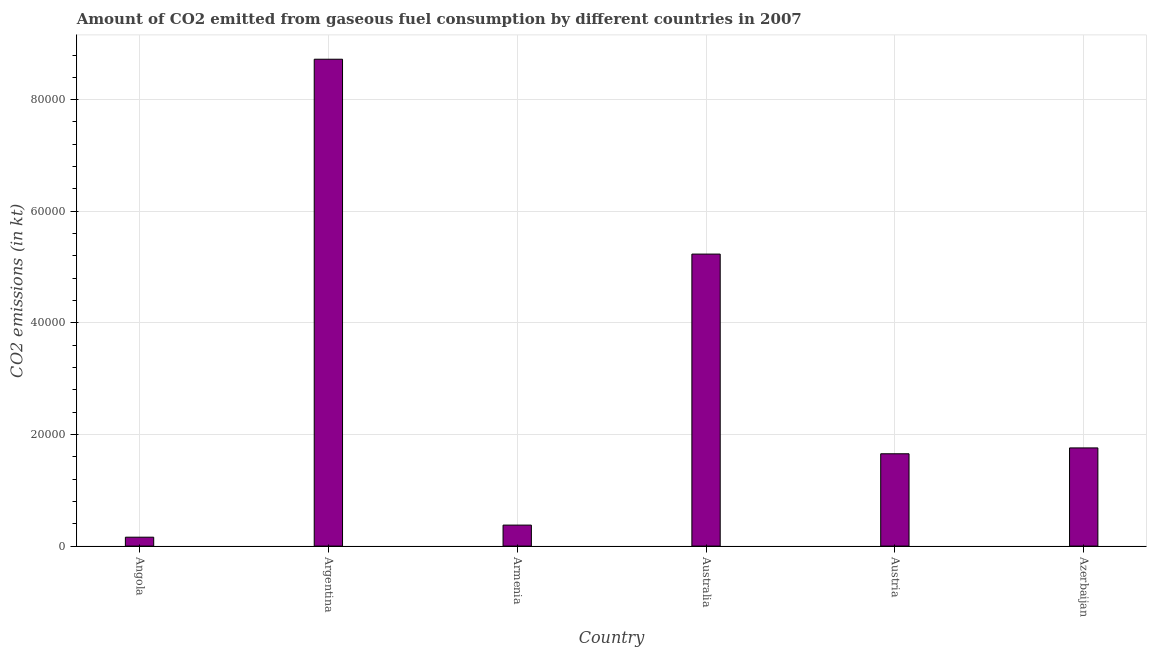Does the graph contain grids?
Offer a very short reply. Yes. What is the title of the graph?
Keep it short and to the point. Amount of CO2 emitted from gaseous fuel consumption by different countries in 2007. What is the label or title of the X-axis?
Offer a terse response. Country. What is the label or title of the Y-axis?
Give a very brief answer. CO2 emissions (in kt). What is the co2 emissions from gaseous fuel consumption in Armenia?
Offer a very short reply. 3762.34. Across all countries, what is the maximum co2 emissions from gaseous fuel consumption?
Ensure brevity in your answer.  8.72e+04. Across all countries, what is the minimum co2 emissions from gaseous fuel consumption?
Offer a terse response. 1595.14. In which country was the co2 emissions from gaseous fuel consumption maximum?
Your answer should be very brief. Argentina. In which country was the co2 emissions from gaseous fuel consumption minimum?
Offer a terse response. Angola. What is the sum of the co2 emissions from gaseous fuel consumption?
Ensure brevity in your answer.  1.79e+05. What is the difference between the co2 emissions from gaseous fuel consumption in Armenia and Australia?
Ensure brevity in your answer.  -4.86e+04. What is the average co2 emissions from gaseous fuel consumption per country?
Make the answer very short. 2.98e+04. What is the median co2 emissions from gaseous fuel consumption?
Give a very brief answer. 1.71e+04. What is the ratio of the co2 emissions from gaseous fuel consumption in Armenia to that in Australia?
Your answer should be very brief. 0.07. What is the difference between the highest and the second highest co2 emissions from gaseous fuel consumption?
Keep it short and to the point. 3.49e+04. Is the sum of the co2 emissions from gaseous fuel consumption in Argentina and Azerbaijan greater than the maximum co2 emissions from gaseous fuel consumption across all countries?
Offer a very short reply. Yes. What is the difference between the highest and the lowest co2 emissions from gaseous fuel consumption?
Your response must be concise. 8.57e+04. How many bars are there?
Make the answer very short. 6. Are all the bars in the graph horizontal?
Offer a very short reply. No. How many countries are there in the graph?
Offer a very short reply. 6. What is the difference between two consecutive major ticks on the Y-axis?
Offer a terse response. 2.00e+04. What is the CO2 emissions (in kt) of Angola?
Offer a very short reply. 1595.14. What is the CO2 emissions (in kt) in Argentina?
Your answer should be very brief. 8.72e+04. What is the CO2 emissions (in kt) in Armenia?
Your answer should be very brief. 3762.34. What is the CO2 emissions (in kt) in Australia?
Give a very brief answer. 5.23e+04. What is the CO2 emissions (in kt) of Austria?
Provide a succinct answer. 1.65e+04. What is the CO2 emissions (in kt) of Azerbaijan?
Offer a terse response. 1.76e+04. What is the difference between the CO2 emissions (in kt) in Angola and Argentina?
Provide a succinct answer. -8.57e+04. What is the difference between the CO2 emissions (in kt) in Angola and Armenia?
Your answer should be very brief. -2167.2. What is the difference between the CO2 emissions (in kt) in Angola and Australia?
Make the answer very short. -5.07e+04. What is the difference between the CO2 emissions (in kt) in Angola and Austria?
Provide a short and direct response. -1.50e+04. What is the difference between the CO2 emissions (in kt) in Angola and Azerbaijan?
Keep it short and to the point. -1.60e+04. What is the difference between the CO2 emissions (in kt) in Argentina and Armenia?
Keep it short and to the point. 8.35e+04. What is the difference between the CO2 emissions (in kt) in Argentina and Australia?
Offer a very short reply. 3.49e+04. What is the difference between the CO2 emissions (in kt) in Argentina and Austria?
Offer a terse response. 7.07e+04. What is the difference between the CO2 emissions (in kt) in Argentina and Azerbaijan?
Your response must be concise. 6.97e+04. What is the difference between the CO2 emissions (in kt) in Armenia and Australia?
Ensure brevity in your answer.  -4.86e+04. What is the difference between the CO2 emissions (in kt) in Armenia and Austria?
Provide a succinct answer. -1.28e+04. What is the difference between the CO2 emissions (in kt) in Armenia and Azerbaijan?
Offer a very short reply. -1.38e+04. What is the difference between the CO2 emissions (in kt) in Australia and Austria?
Ensure brevity in your answer.  3.58e+04. What is the difference between the CO2 emissions (in kt) in Australia and Azerbaijan?
Make the answer very short. 3.47e+04. What is the difference between the CO2 emissions (in kt) in Austria and Azerbaijan?
Your answer should be very brief. -1048.76. What is the ratio of the CO2 emissions (in kt) in Angola to that in Argentina?
Keep it short and to the point. 0.02. What is the ratio of the CO2 emissions (in kt) in Angola to that in Armenia?
Your response must be concise. 0.42. What is the ratio of the CO2 emissions (in kt) in Angola to that in Australia?
Ensure brevity in your answer.  0.03. What is the ratio of the CO2 emissions (in kt) in Angola to that in Austria?
Offer a terse response. 0.1. What is the ratio of the CO2 emissions (in kt) in Angola to that in Azerbaijan?
Your response must be concise. 0.09. What is the ratio of the CO2 emissions (in kt) in Argentina to that in Armenia?
Offer a terse response. 23.19. What is the ratio of the CO2 emissions (in kt) in Argentina to that in Australia?
Ensure brevity in your answer.  1.67. What is the ratio of the CO2 emissions (in kt) in Argentina to that in Austria?
Ensure brevity in your answer.  5.27. What is the ratio of the CO2 emissions (in kt) in Argentina to that in Azerbaijan?
Offer a terse response. 4.96. What is the ratio of the CO2 emissions (in kt) in Armenia to that in Australia?
Give a very brief answer. 0.07. What is the ratio of the CO2 emissions (in kt) in Armenia to that in Austria?
Offer a terse response. 0.23. What is the ratio of the CO2 emissions (in kt) in Armenia to that in Azerbaijan?
Offer a very short reply. 0.21. What is the ratio of the CO2 emissions (in kt) in Australia to that in Austria?
Your answer should be compact. 3.16. What is the ratio of the CO2 emissions (in kt) in Australia to that in Azerbaijan?
Offer a very short reply. 2.97. 